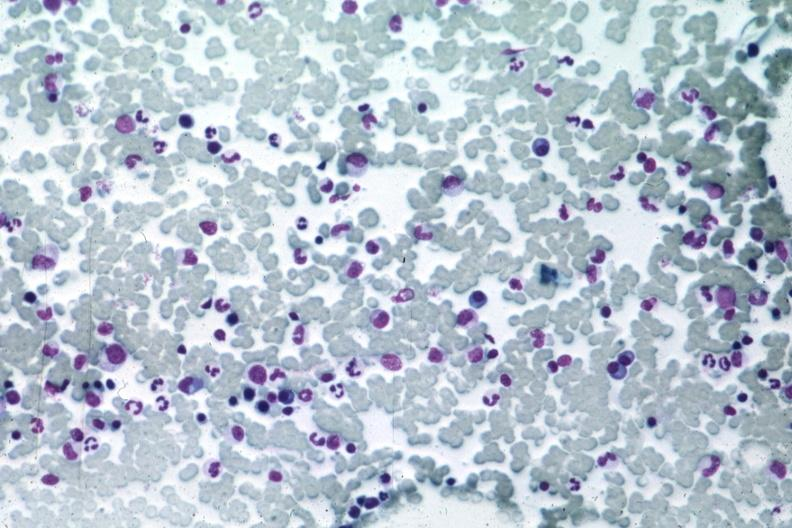does this image show med many atypical plasma cells easily seen?
Answer the question using a single word or phrase. Yes 